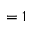<formula> <loc_0><loc_0><loc_500><loc_500>= 1</formula> 